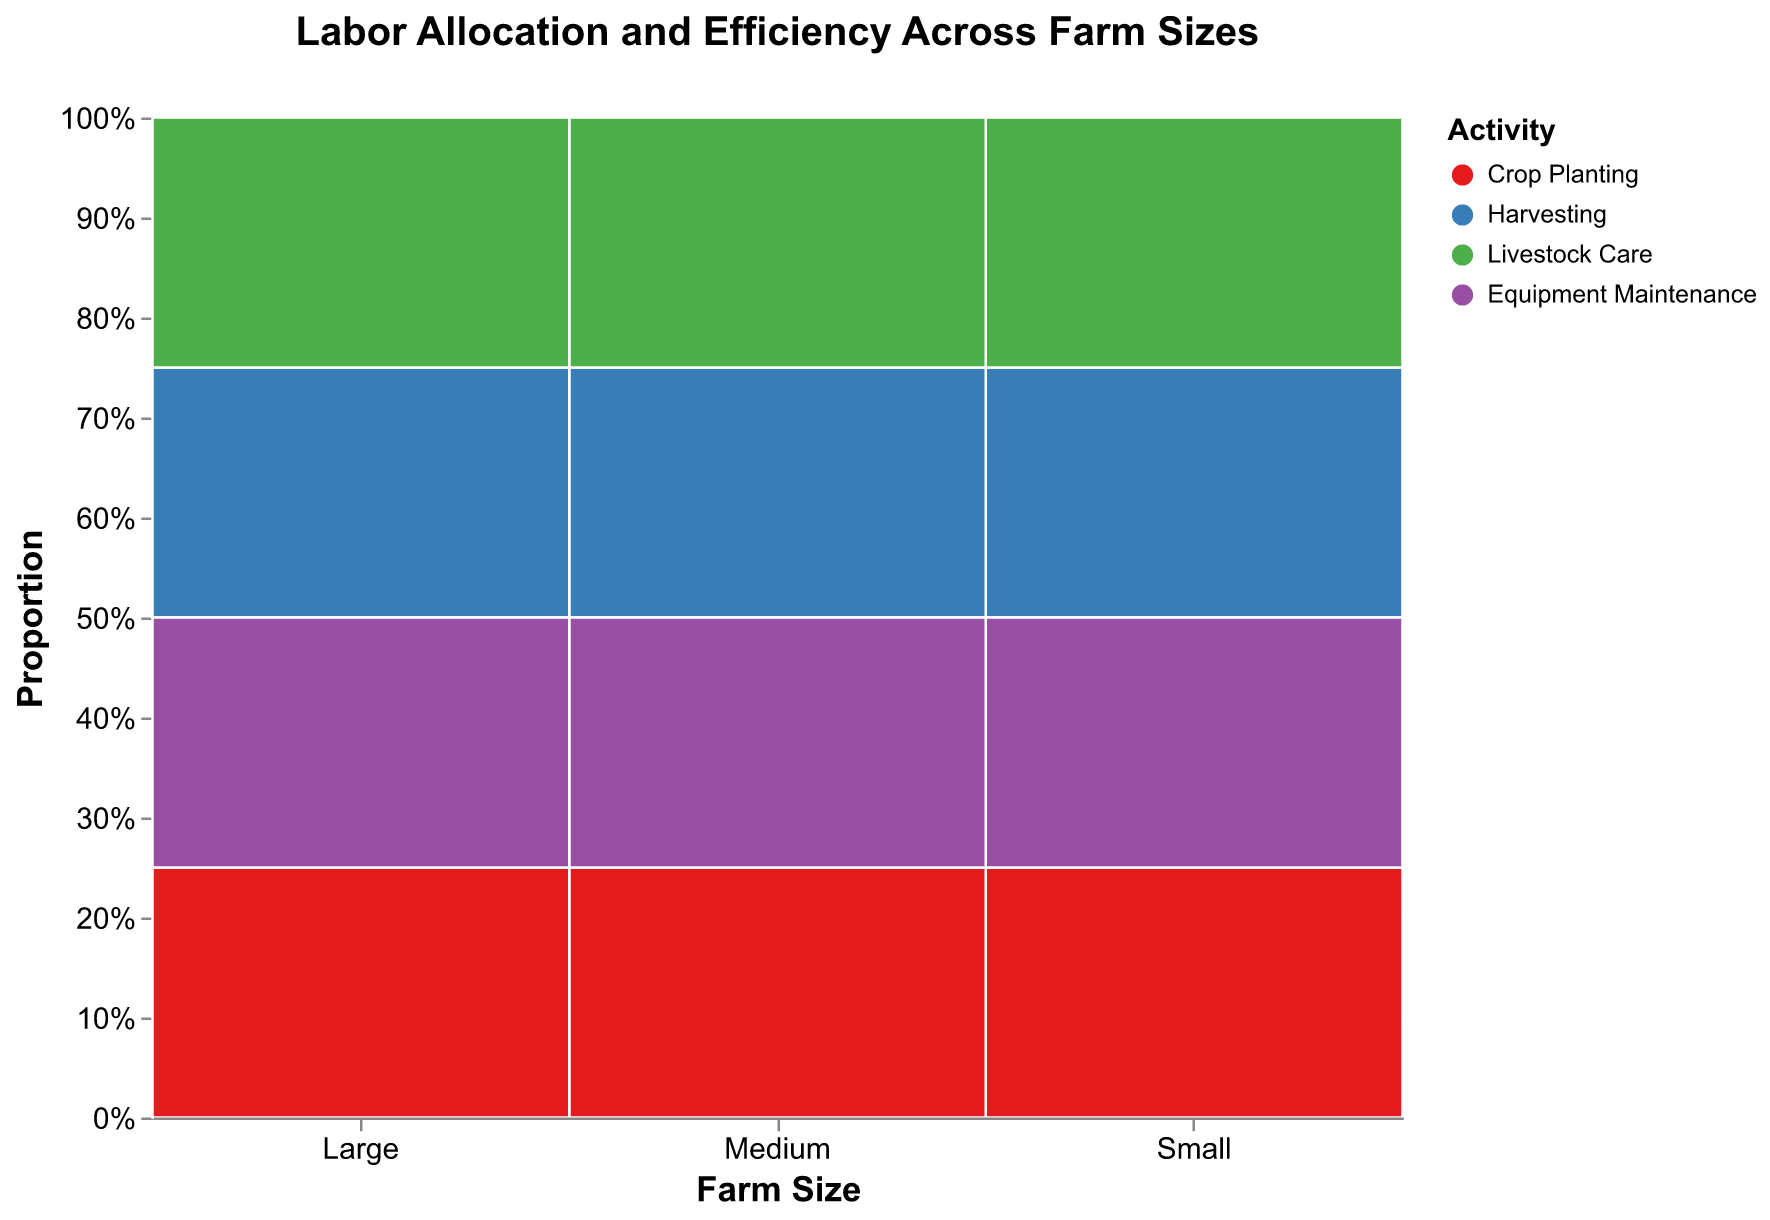What activities are included in the plot? From the visual information, the activities represented by different colors are Crop Planting, Harvesting, Livestock Care, and Equipment Maintenance.
Answer: Crop Planting, Harvesting, Livestock Care, Equipment Maintenance Which farm size has the highest labor allocation for each activity? We can look at the proportion of each color segment in each farm size column. For Crop Planting (red), the Large farm has the largest portion. For Harvesting (blue), the Large farm has the highest segment. For Livestock Care (green), the Large farm also has the most significant portion. For Equipment Maintenance (purple), again, the Large farm has the highest allocation.
Answer: Large farm What is the efficiency rating of Livestock Care activities across different farm sizes? By looking at the text within the green segments for Livestock Care, we can see that Small and Medium farms both have a "High" rating, while the Large farm has a "Low" rating.
Answer: Small: High, Medium: High, Large: Low How does the efficiency rating of harvesting compare across different farm sizes? Observing the text within the blue segments for Harvesting, all the farm sizes (Small, Medium, and Large) have a "High" efficiency rating.
Answer: All High How does labor allocation for Crop Planting compare between Small and Medium farm sizes? Crop Planting is represented by the red color. Comparatively, the Small farm has a smaller red segment compared to Medium, indicating fewer labor hours allocated for Crop Planting in the Small farm compared to Medium.
Answer: Medium has more Which activity in the Small farm has the lowest efficiency rating? For the Small farm, the colors and their text labels can be used. Equipment Maintenance (purple) in the Small farm shows a "Low" efficiency rating.
Answer: Equipment Maintenance What is the total proportion of labor hours spent on Equipment Maintenance across all farm sizes? Adding the proportion of the purple segments from all farm sizes would give the total proportion of labor hours on Equipment Maintenance. Small farm: approx. 10%, Medium farm: approx. 16%, Large farm: approx. 20%. Combined gives a rough estimate.
Answer: Approx. 46% Does the proportion of labor allocated to Livestock Care show an increasing or decreasing trend from Small to Large farm sizes? By observing the green segments, it's evident that the proportion decreases from Small to Medium, and then to Large.
Answer: Decreasing Compare the overall efficiency rating of Crop Planting and Livestock Care activities. Crop Planting (red) has a high efficiency rating across Medium and Large farms, while Livestock Care (green) has a high rating in Small and Medium farms but a low rating in Large farms. Crop Planting generally has higher efficiency overall.
Answer: Crop Planting generally higher 